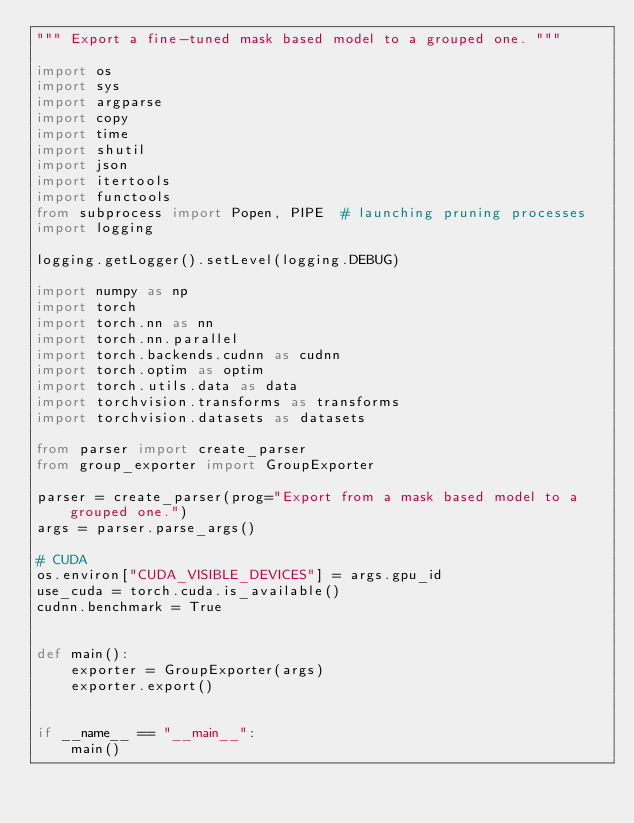Convert code to text. <code><loc_0><loc_0><loc_500><loc_500><_Python_>""" Export a fine-tuned mask based model to a grouped one. """

import os
import sys
import argparse
import copy
import time
import shutil
import json
import itertools
import functools
from subprocess import Popen, PIPE  # launching pruning processes
import logging

logging.getLogger().setLevel(logging.DEBUG)

import numpy as np
import torch
import torch.nn as nn
import torch.nn.parallel
import torch.backends.cudnn as cudnn
import torch.optim as optim
import torch.utils.data as data
import torchvision.transforms as transforms
import torchvision.datasets as datasets

from parser import create_parser
from group_exporter import GroupExporter

parser = create_parser(prog="Export from a mask based model to a grouped one.")
args = parser.parse_args()

# CUDA
os.environ["CUDA_VISIBLE_DEVICES"] = args.gpu_id
use_cuda = torch.cuda.is_available()
cudnn.benchmark = True


def main():
    exporter = GroupExporter(args)
    exporter.export()


if __name__ == "__main__":
    main()
</code> 